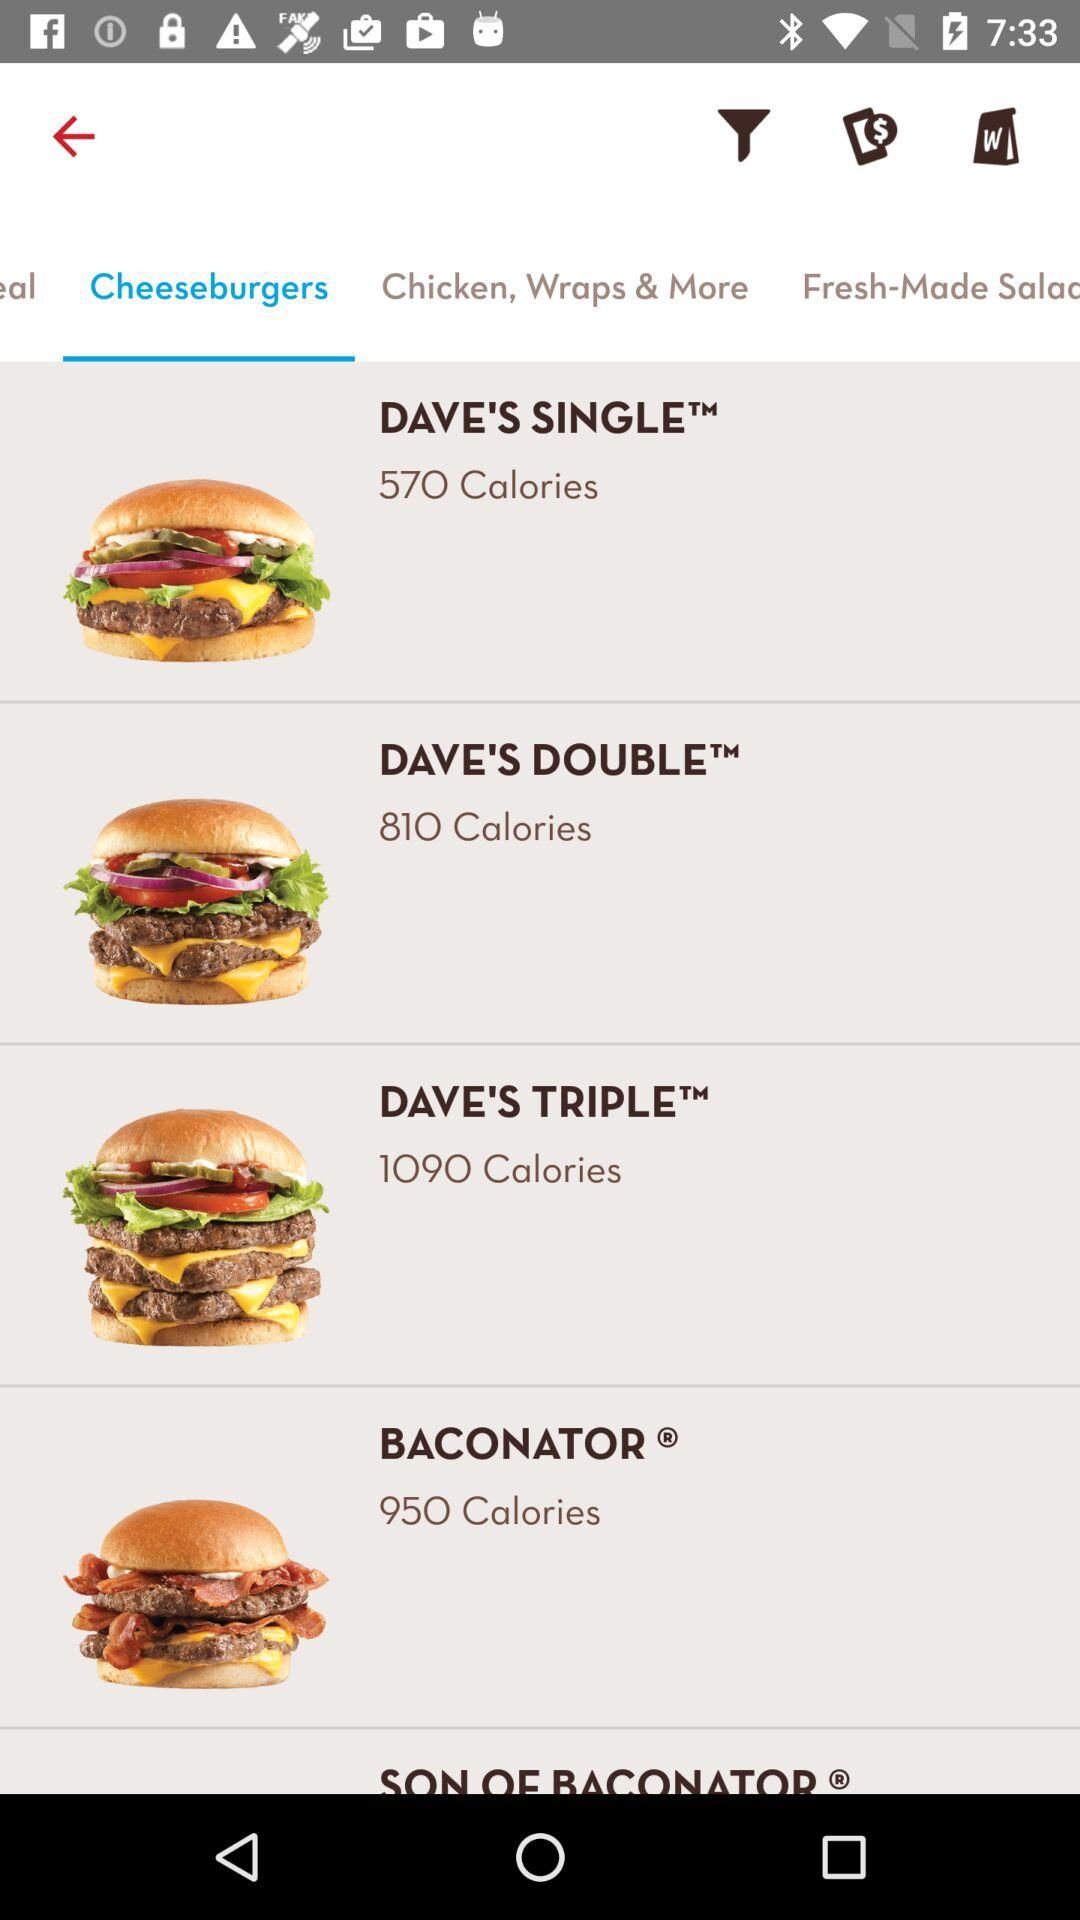What does the list of cheeseburgers contain? The list contains Dave's Single, Dave's Double, Dave's Triple and Baconator. 